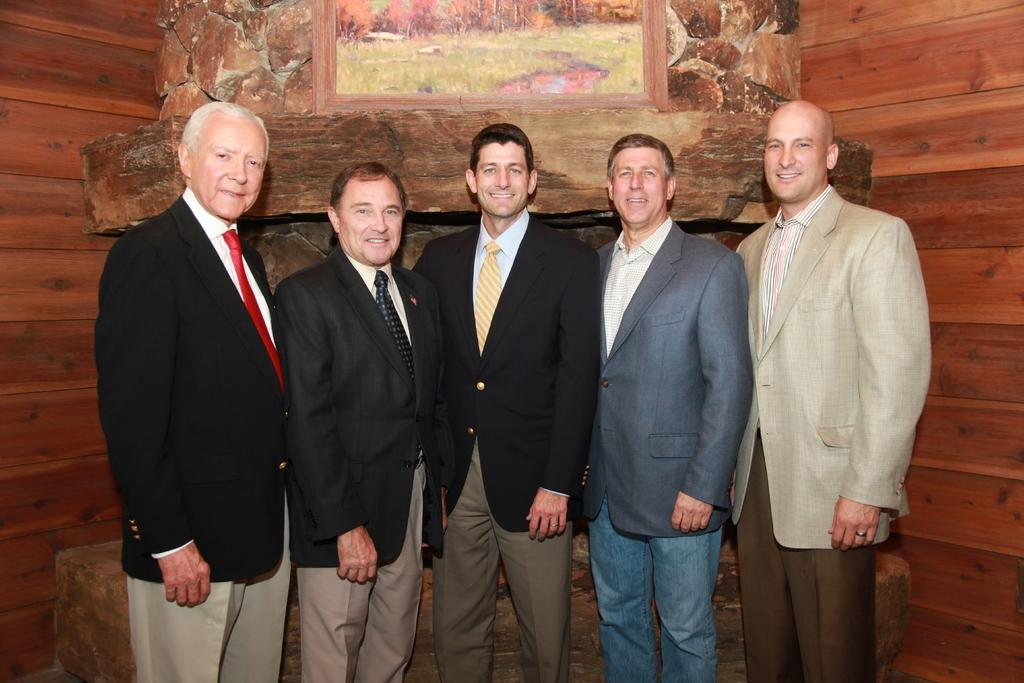What can be seen in the image? There are people standing in the image. Can you describe the clothing of the people? The people are wearing different color dresses. What is visible in the background of the image? There is a frame visible in the background. What is the color of the background? The background has a brown color. Can you tell me how many nerves are visible in the image? There are no nerves visible in the image; it features people standing and a background with a brown color. 